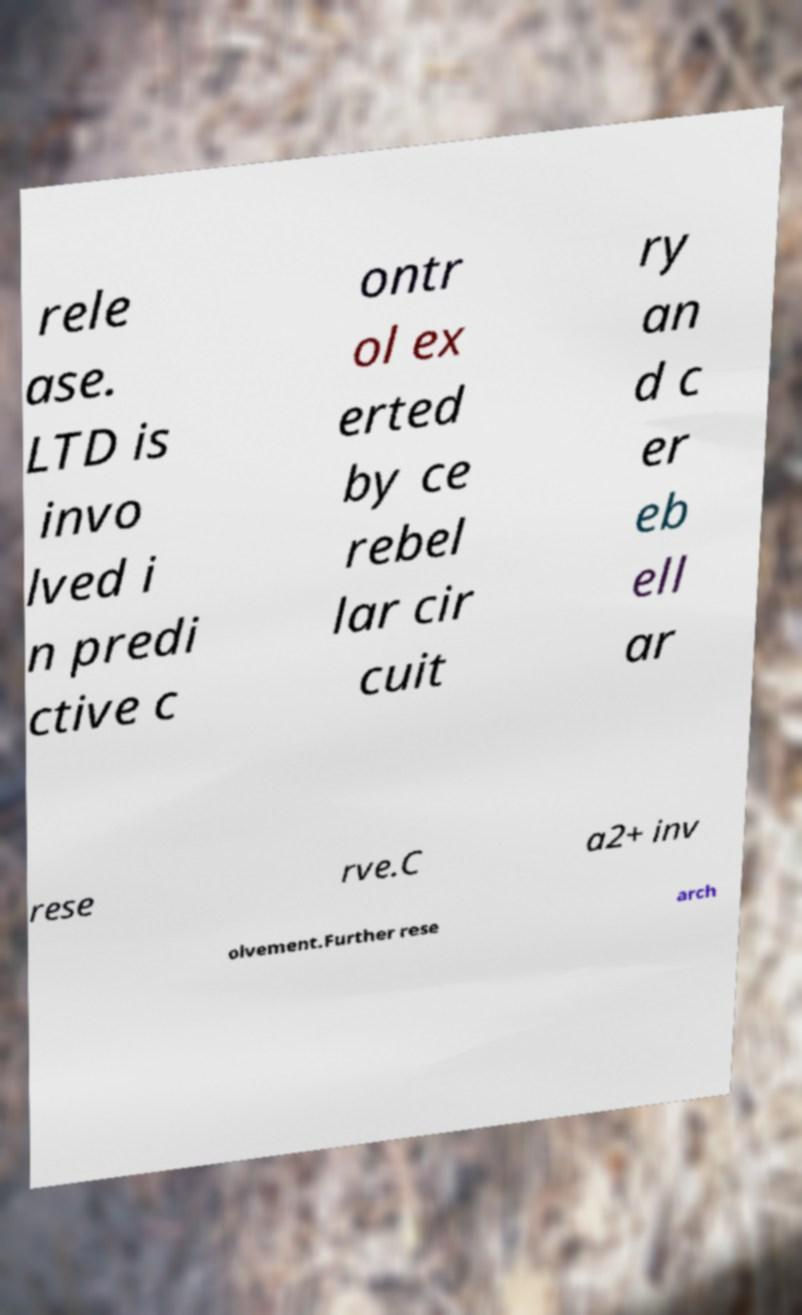There's text embedded in this image that I need extracted. Can you transcribe it verbatim? rele ase. LTD is invo lved i n predi ctive c ontr ol ex erted by ce rebel lar cir cuit ry an d c er eb ell ar rese rve.C a2+ inv olvement.Further rese arch 